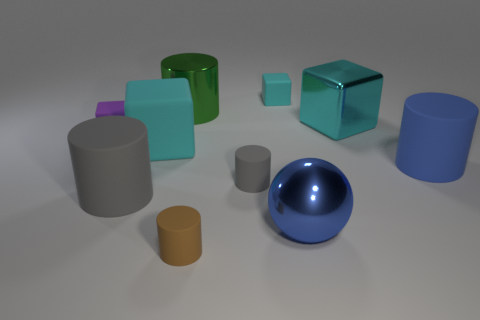Subtract all cyan blocks. How many were subtracted if there are1cyan blocks left? 2 Subtract all purple cylinders. How many cyan cubes are left? 3 Subtract all big gray cylinders. How many cylinders are left? 4 Subtract all brown cylinders. How many cylinders are left? 4 Subtract 1 blocks. How many blocks are left? 3 Subtract all purple cylinders. Subtract all green spheres. How many cylinders are left? 5 Subtract all blocks. How many objects are left? 6 Subtract 1 blue spheres. How many objects are left? 9 Subtract all small cyan matte objects. Subtract all big green objects. How many objects are left? 8 Add 7 purple things. How many purple things are left? 8 